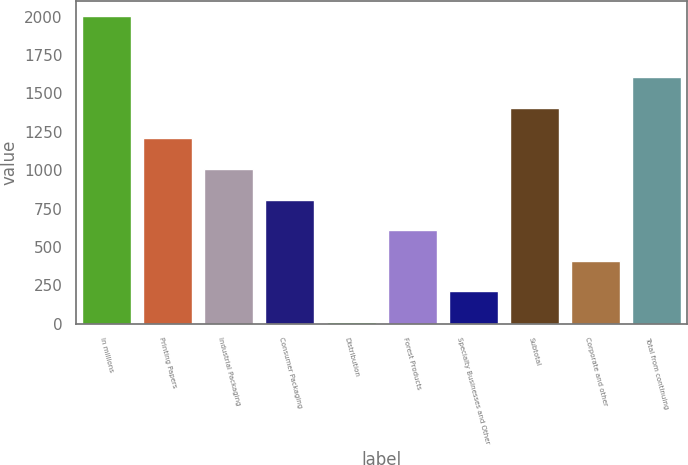Convert chart. <chart><loc_0><loc_0><loc_500><loc_500><bar_chart><fcel>In millions<fcel>Printing Papers<fcel>Industrial Packaging<fcel>Consumer Packaging<fcel>Distribution<fcel>Forest Products<fcel>Specialty Businesses and Other<fcel>Subtotal<fcel>Corporate and other<fcel>Total from continuing<nl><fcel>2003<fcel>1206.6<fcel>1007.5<fcel>808.4<fcel>12<fcel>609.3<fcel>211.1<fcel>1405.7<fcel>410.2<fcel>1604.8<nl></chart> 